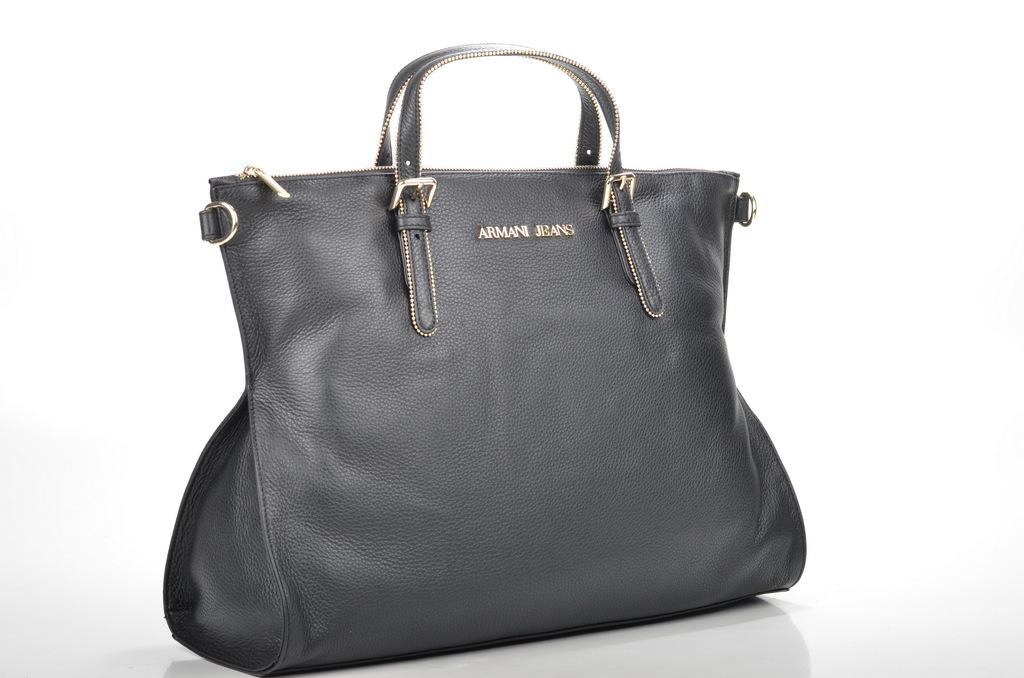What object can be seen in the image? There is a handbag in the image. What is the color of the handbag? The handbag is black in color. Can you provide an example of a belief held by the handbag in the image? There is no indication in the image that the handbag holds any beliefs, as it is an inanimate object. 